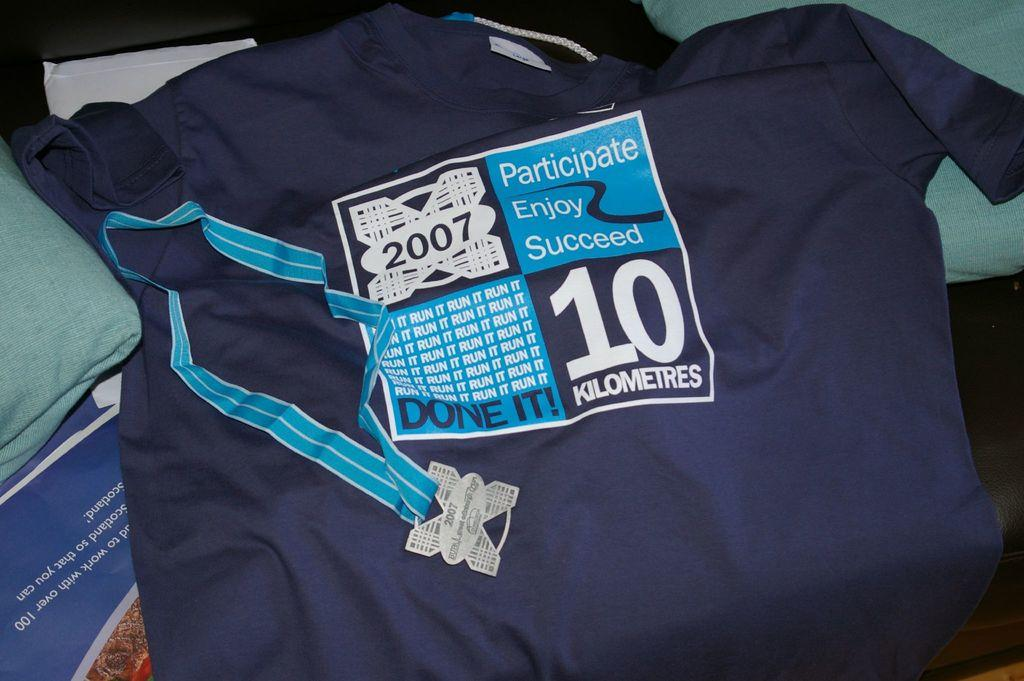<image>
Describe the image concisely. A shirt is given to those who participate, enjoy and succeed in the 10 kilometer race. 